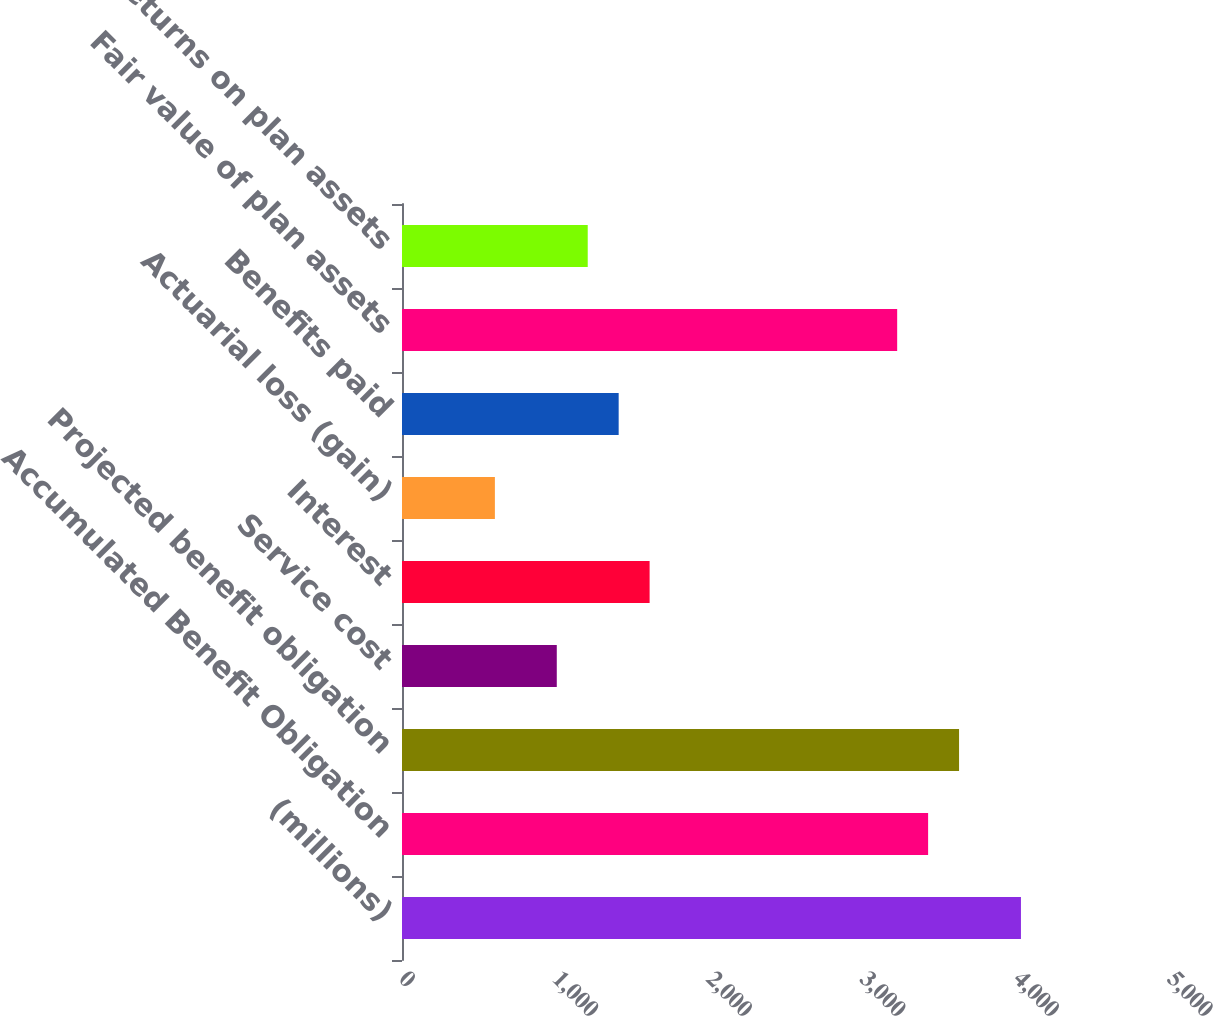Convert chart to OTSL. <chart><loc_0><loc_0><loc_500><loc_500><bar_chart><fcel>(millions)<fcel>Accumulated Benefit Obligation<fcel>Projected benefit obligation<fcel>Service cost<fcel>Interest<fcel>Actuarial loss (gain)<fcel>Benefits paid<fcel>Fair value of plan assets<fcel>Actual returns on plan assets<nl><fcel>4029.6<fcel>3425.22<fcel>3626.68<fcel>1007.7<fcel>1612.08<fcel>604.78<fcel>1410.62<fcel>3223.76<fcel>1209.16<nl></chart> 